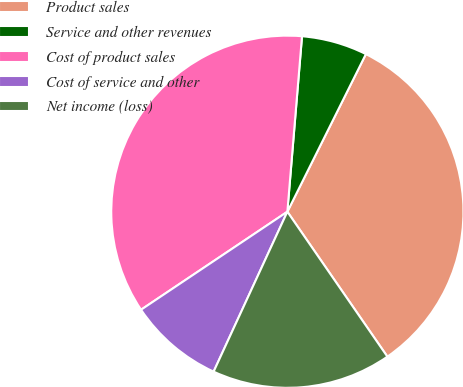<chart> <loc_0><loc_0><loc_500><loc_500><pie_chart><fcel>Product sales<fcel>Service and other revenues<fcel>Cost of product sales<fcel>Cost of service and other<fcel>Net income (loss)<nl><fcel>33.03%<fcel>6.03%<fcel>35.72%<fcel>8.73%<fcel>16.49%<nl></chart> 